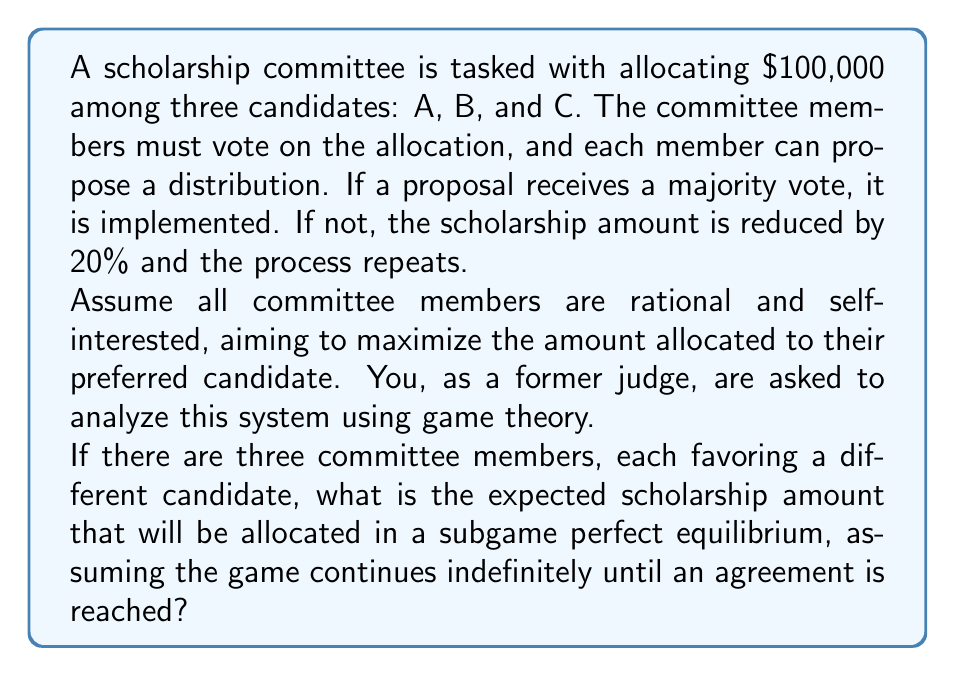Help me with this question. To analyze this problem, we'll use the concept of subgame perfect equilibrium in game theory. Here's a step-by-step approach:

1) First, let's consider the incentives of each committee member. They want to maximize the amount for their preferred candidate while ensuring an agreement is reached to avoid further reductions.

2) In a subgame perfect equilibrium, we need to consider what would happen at each stage of the game, working backwards from potential end states.

3) Let's denote the total amount to be allocated at any stage as $x$. Initially, $x = 100,000$.

4) If no agreement is reached, the amount for the next round becomes $0.8x$.

5) In equilibrium, the proposer will offer the minimum amount that will be accepted by at least one other member, ensuring a majority.

6) The key insight is that any rational member will accept a proposal if their share is at least as much as they expect to get in the next round if the proposal is rejected.

7) In the next round, if selected as the proposer (with 1/3 probability), a member expects to get $0.8x$. If not selected (2/3 probability), they expect to get $0.8x/3$ (assuming an equal split among non-proposers in the next equilibrium proposal).

8) Therefore, the expected value for a member in the next round is:

   $$E = \frac{1}{3}(0.8x) + \frac{2}{3}(\frac{0.8x}{3}) = \frac{4}{9}(0.8x) = \frac{32}{90}x$$

9) So, in equilibrium, the proposer will offer $\frac{32}{90}x$ to one other member, keep $1 - \frac{32}{90}x = \frac{58}{90}x$ for themselves, and give nothing to the third member.

10) This proposal will be accepted, as one member gets the same as their expected value from continuing, while the other prefers 0 now to a chance of a positive amount later (as the total amount decreases each round).

11) Therefore, the equilibrium allocation will occur in the first round, with no reduction in the scholarship amount.
Answer: The expected scholarship amount allocated in a subgame perfect equilibrium is $100,000, with a distribution of $\frac{58}{90}(100,000) \approx 64,444$ to the proposer's preferred candidate, $\frac{32}{90}(100,000) \approx 35,556$ to one other candidate, and $0 to the third candidate. 